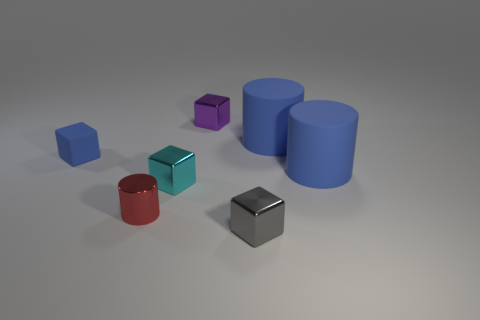Add 3 small blue spheres. How many objects exist? 10 Subtract all brown cubes. Subtract all cyan cylinders. How many cubes are left? 4 Subtract all cylinders. How many objects are left? 4 Subtract all small purple rubber blocks. Subtract all blue cylinders. How many objects are left? 5 Add 5 tiny purple cubes. How many tiny purple cubes are left? 6 Add 2 red metallic balls. How many red metallic balls exist? 2 Subtract 0 green cubes. How many objects are left? 7 